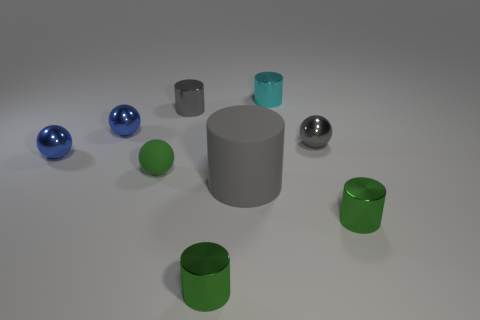Does the tiny rubber sphere have the same color as the large cylinder?
Give a very brief answer. No. What is the material of the cyan thing that is the same shape as the big gray rubber object?
Offer a terse response. Metal. Is there anything else that has the same material as the small gray cylinder?
Make the answer very short. Yes. Is the number of tiny metallic cylinders behind the gray rubber cylinder the same as the number of rubber balls behind the cyan metal cylinder?
Your answer should be compact. No. Does the big thing have the same material as the green sphere?
Your answer should be very brief. Yes. What number of cyan things are either big cylinders or cylinders?
Your response must be concise. 1. What number of other small cyan shiny things have the same shape as the small cyan shiny object?
Provide a short and direct response. 0. What material is the tiny green sphere?
Provide a short and direct response. Rubber. Is the number of blue balls behind the small gray cylinder the same as the number of green things?
Your answer should be very brief. No. The cyan shiny object that is the same size as the rubber sphere is what shape?
Provide a succinct answer. Cylinder. 